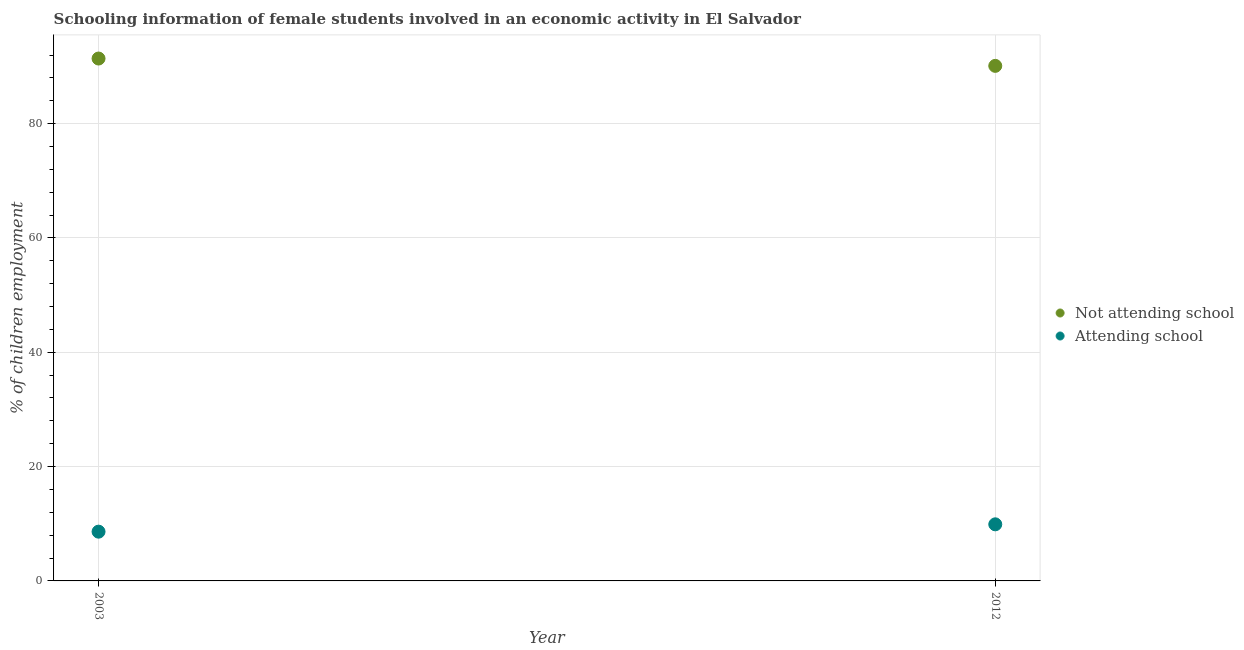How many different coloured dotlines are there?
Give a very brief answer. 2. What is the percentage of employed females who are attending school in 2012?
Provide a short and direct response. 9.9. Across all years, what is the maximum percentage of employed females who are attending school?
Your answer should be compact. 9.9. Across all years, what is the minimum percentage of employed females who are not attending school?
Make the answer very short. 90.1. What is the total percentage of employed females who are not attending school in the graph?
Your answer should be compact. 181.48. What is the difference between the percentage of employed females who are not attending school in 2003 and that in 2012?
Provide a short and direct response. 1.28. What is the difference between the percentage of employed females who are not attending school in 2003 and the percentage of employed females who are attending school in 2012?
Give a very brief answer. 81.48. What is the average percentage of employed females who are attending school per year?
Your answer should be compact. 9.26. In the year 2012, what is the difference between the percentage of employed females who are attending school and percentage of employed females who are not attending school?
Your response must be concise. -80.2. In how many years, is the percentage of employed females who are attending school greater than 40 %?
Offer a very short reply. 0. What is the ratio of the percentage of employed females who are attending school in 2003 to that in 2012?
Your response must be concise. 0.87. Is the percentage of employed females who are attending school strictly greater than the percentage of employed females who are not attending school over the years?
Keep it short and to the point. No. Is the percentage of employed females who are not attending school strictly less than the percentage of employed females who are attending school over the years?
Provide a succinct answer. No. How many dotlines are there?
Offer a very short reply. 2. What is the difference between two consecutive major ticks on the Y-axis?
Give a very brief answer. 20. Are the values on the major ticks of Y-axis written in scientific E-notation?
Keep it short and to the point. No. Does the graph contain any zero values?
Your answer should be compact. No. Where does the legend appear in the graph?
Give a very brief answer. Center right. How many legend labels are there?
Your answer should be very brief. 2. How are the legend labels stacked?
Make the answer very short. Vertical. What is the title of the graph?
Ensure brevity in your answer.  Schooling information of female students involved in an economic activity in El Salvador. What is the label or title of the X-axis?
Ensure brevity in your answer.  Year. What is the label or title of the Y-axis?
Provide a succinct answer. % of children employment. What is the % of children employment in Not attending school in 2003?
Ensure brevity in your answer.  91.38. What is the % of children employment of Attending school in 2003?
Provide a short and direct response. 8.62. What is the % of children employment in Not attending school in 2012?
Your answer should be compact. 90.1. What is the % of children employment in Attending school in 2012?
Make the answer very short. 9.9. Across all years, what is the maximum % of children employment of Not attending school?
Keep it short and to the point. 91.38. Across all years, what is the maximum % of children employment in Attending school?
Provide a short and direct response. 9.9. Across all years, what is the minimum % of children employment of Not attending school?
Offer a very short reply. 90.1. Across all years, what is the minimum % of children employment in Attending school?
Give a very brief answer. 8.62. What is the total % of children employment in Not attending school in the graph?
Your answer should be very brief. 181.48. What is the total % of children employment in Attending school in the graph?
Provide a succinct answer. 18.52. What is the difference between the % of children employment in Not attending school in 2003 and that in 2012?
Your answer should be compact. 1.28. What is the difference between the % of children employment in Attending school in 2003 and that in 2012?
Provide a short and direct response. -1.28. What is the difference between the % of children employment in Not attending school in 2003 and the % of children employment in Attending school in 2012?
Ensure brevity in your answer.  81.48. What is the average % of children employment in Not attending school per year?
Offer a terse response. 90.74. What is the average % of children employment of Attending school per year?
Offer a very short reply. 9.26. In the year 2003, what is the difference between the % of children employment of Not attending school and % of children employment of Attending school?
Provide a succinct answer. 82.77. In the year 2012, what is the difference between the % of children employment of Not attending school and % of children employment of Attending school?
Keep it short and to the point. 80.2. What is the ratio of the % of children employment of Not attending school in 2003 to that in 2012?
Offer a very short reply. 1.01. What is the ratio of the % of children employment in Attending school in 2003 to that in 2012?
Provide a short and direct response. 0.87. What is the difference between the highest and the second highest % of children employment in Not attending school?
Offer a terse response. 1.28. What is the difference between the highest and the second highest % of children employment of Attending school?
Offer a very short reply. 1.28. What is the difference between the highest and the lowest % of children employment of Not attending school?
Provide a short and direct response. 1.28. What is the difference between the highest and the lowest % of children employment of Attending school?
Ensure brevity in your answer.  1.28. 